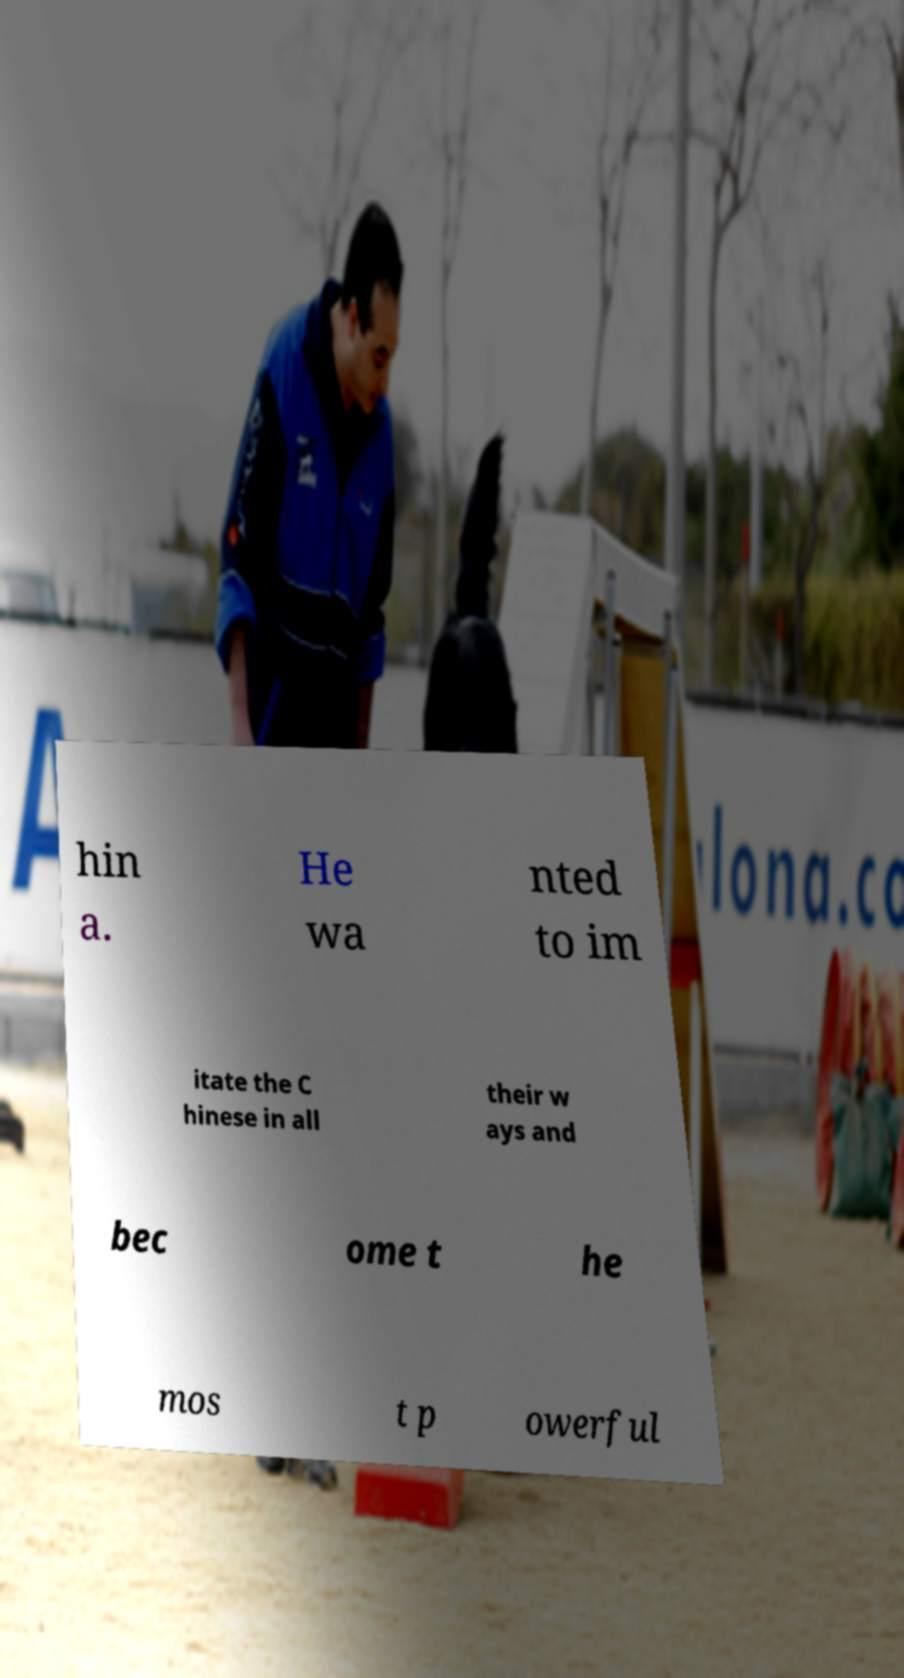Please identify and transcribe the text found in this image. hin a. He wa nted to im itate the C hinese in all their w ays and bec ome t he mos t p owerful 